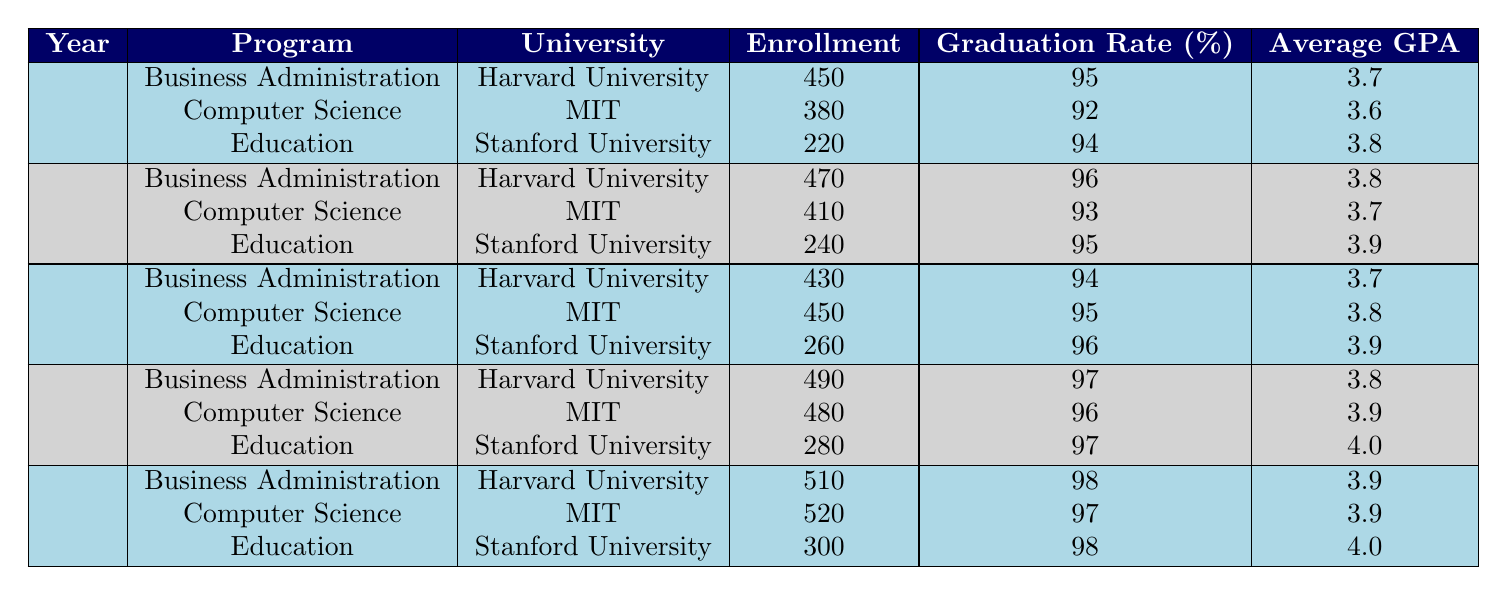What was the enrollment count in Education at Stanford University in 2021? Looking at the table, the enrollment count for the Education program at Stanford University in 2021 is specifically listed as 280.
Answer: 280 What is the graduation rate for Business Administration at Harvard University in 2022? The table indicates that the graduation rate for the Business Administration program at Harvard University in 2022 is 98%.
Answer: 98 Which program had the highest enrollment count in 2019? In 2019, the enrollment counts are: Business Administration 470, Computer Science 410, and Education 240. Since 470 is the highest value, Business Administration had the most enrollments in 2019.
Answer: Business Administration What is the average GPA for Computer Science across all years? The average GPA for Computer Science is given for each year: in 2018 it is 3.6, 2019 it is 3.7, 2020 it is 3.8, 2021 it is 3.9, and 2022 it is 3.9. Calculating the average: (3.6 + 3.7 + 3.8 + 3.9 + 3.9) / 5 = 3.78.
Answer: 3.78 Did the enrollment count in Education at Stanford University increase from 2018 to 2022? In 2018, the enrollment was 220, in 2019 it was 240, in 2020 it was 260, in 2021 it was 280, and in 2022 it was 300. Since all these values are increasing, the enrollment count did go up.
Answer: Yes What was the total enrollment across all programs at MIT in 2020? The enrollment counts for MIT in 2020 are: Computer Science 450. Since this is the only program listed for MIT in 2020, the total enrollment is simply 450.
Answer: 450 Which year saw the highest enrollment in Business Administration, and what was the count? Looking at the Business Administration enrollments: 2018 has 450, 2019 has 470, 2020 has 430, 2021 has 490, and 2022 has 510. The highest is in 2022 at a count of 510.
Answer: 2022, 510 Is it true that all programs at Stanford University had graduation rates above 95% in 2021? For 2021, Education had a graduation rate of 97%. Business Administration is not listed for Stanford in 2021, implying that we do not have complete data. However, Education is above 95%, indicating at least one program is.
Answer: No What was the difference in enrollment count between Business Administration at Harvard University in 2021 and Computer Science at MIT in the same year? The enrollment count for Business Administration at Harvard in 2021 is 490 and for Computer Science at MIT is 480. The difference is 490 - 480 = 10.
Answer: 10 